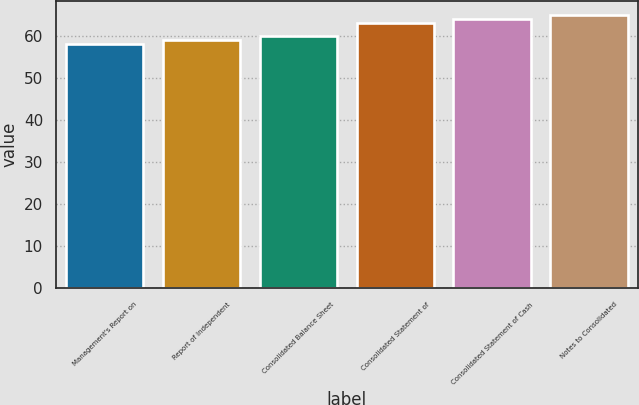Convert chart to OTSL. <chart><loc_0><loc_0><loc_500><loc_500><bar_chart><fcel>Management's Report on<fcel>Report of Independent<fcel>Consolidated Balance Sheet<fcel>Consolidated Statement of<fcel>Consolidated Statement of Cash<fcel>Notes to Consolidated<nl><fcel>58<fcel>59<fcel>60<fcel>63<fcel>64<fcel>65<nl></chart> 